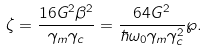Convert formula to latex. <formula><loc_0><loc_0><loc_500><loc_500>\zeta = \frac { 1 6 G ^ { 2 } \beta ^ { 2 } } { \gamma _ { m } \gamma _ { c } } = \frac { 6 4 G ^ { 2 } } { \hbar { \omega } _ { 0 } \gamma _ { m } \gamma _ { c } ^ { 2 } } \wp .</formula> 